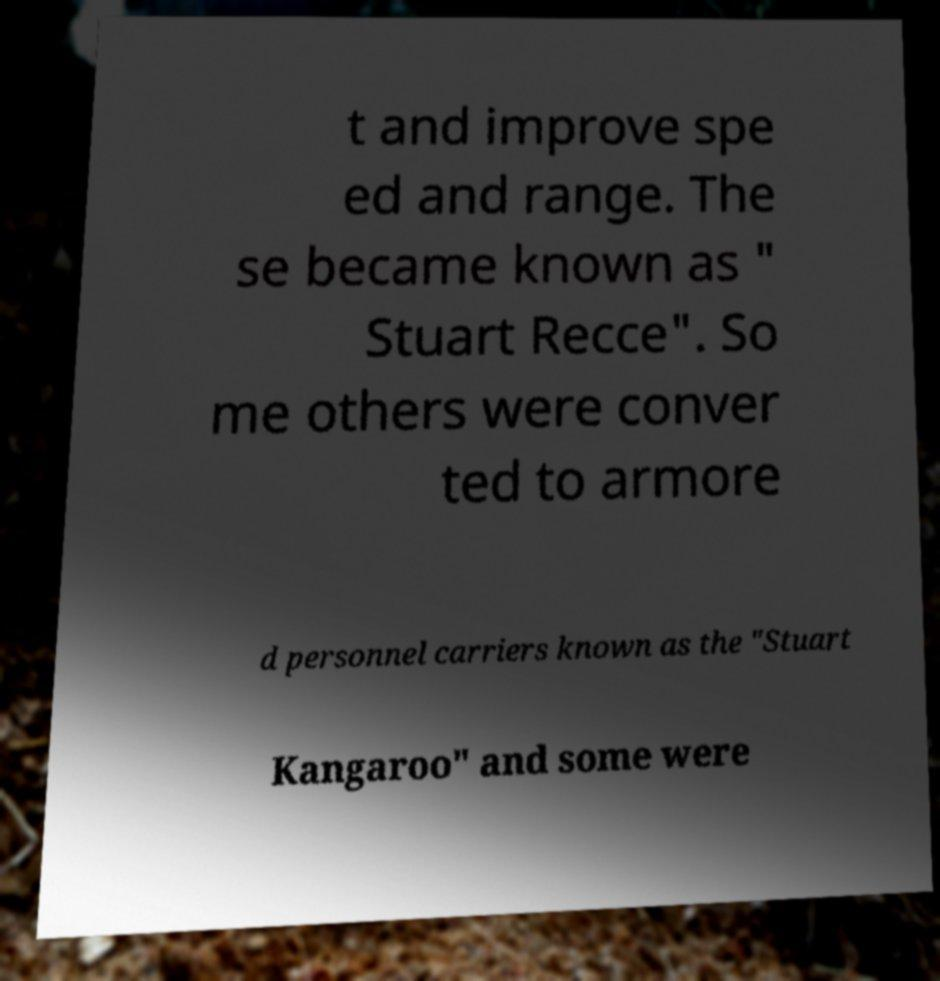Can you accurately transcribe the text from the provided image for me? t and improve spe ed and range. The se became known as " Stuart Recce". So me others were conver ted to armore d personnel carriers known as the "Stuart Kangaroo" and some were 